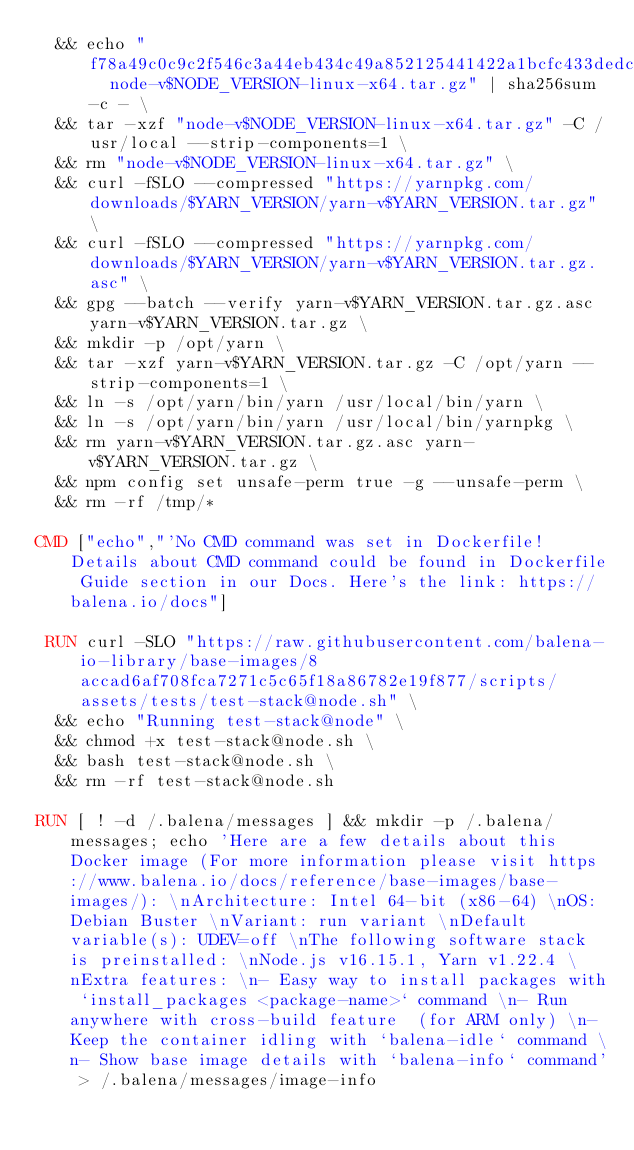<code> <loc_0><loc_0><loc_500><loc_500><_Dockerfile_>	&& echo "f78a49c0c9c2f546c3a44eb434c49a852125441422a1bcfc433dedc58d6a241c  node-v$NODE_VERSION-linux-x64.tar.gz" | sha256sum -c - \
	&& tar -xzf "node-v$NODE_VERSION-linux-x64.tar.gz" -C /usr/local --strip-components=1 \
	&& rm "node-v$NODE_VERSION-linux-x64.tar.gz" \
	&& curl -fSLO --compressed "https://yarnpkg.com/downloads/$YARN_VERSION/yarn-v$YARN_VERSION.tar.gz" \
	&& curl -fSLO --compressed "https://yarnpkg.com/downloads/$YARN_VERSION/yarn-v$YARN_VERSION.tar.gz.asc" \
	&& gpg --batch --verify yarn-v$YARN_VERSION.tar.gz.asc yarn-v$YARN_VERSION.tar.gz \
	&& mkdir -p /opt/yarn \
	&& tar -xzf yarn-v$YARN_VERSION.tar.gz -C /opt/yarn --strip-components=1 \
	&& ln -s /opt/yarn/bin/yarn /usr/local/bin/yarn \
	&& ln -s /opt/yarn/bin/yarn /usr/local/bin/yarnpkg \
	&& rm yarn-v$YARN_VERSION.tar.gz.asc yarn-v$YARN_VERSION.tar.gz \
	&& npm config set unsafe-perm true -g --unsafe-perm \
	&& rm -rf /tmp/*

CMD ["echo","'No CMD command was set in Dockerfile! Details about CMD command could be found in Dockerfile Guide section in our Docs. Here's the link: https://balena.io/docs"]

 RUN curl -SLO "https://raw.githubusercontent.com/balena-io-library/base-images/8accad6af708fca7271c5c65f18a86782e19f877/scripts/assets/tests/test-stack@node.sh" \
  && echo "Running test-stack@node" \
  && chmod +x test-stack@node.sh \
  && bash test-stack@node.sh \
  && rm -rf test-stack@node.sh 

RUN [ ! -d /.balena/messages ] && mkdir -p /.balena/messages; echo 'Here are a few details about this Docker image (For more information please visit https://www.balena.io/docs/reference/base-images/base-images/): \nArchitecture: Intel 64-bit (x86-64) \nOS: Debian Buster \nVariant: run variant \nDefault variable(s): UDEV=off \nThe following software stack is preinstalled: \nNode.js v16.15.1, Yarn v1.22.4 \nExtra features: \n- Easy way to install packages with `install_packages <package-name>` command \n- Run anywhere with cross-build feature  (for ARM only) \n- Keep the container idling with `balena-idle` command \n- Show base image details with `balena-info` command' > /.balena/messages/image-info</code> 